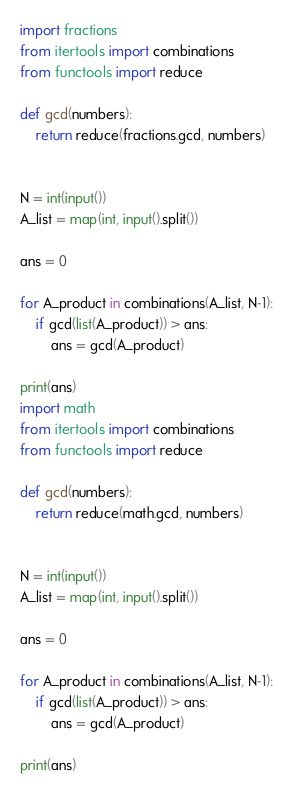<code> <loc_0><loc_0><loc_500><loc_500><_Python_>import fractions
from itertools import combinations
from functools import reduce
 
def gcd(numbers):
    return reduce(fractions.gcd, numbers)
 
 
N = int(input())
A_list = map(int, input().split())
 
ans = 0
 
for A_product in combinations(A_list, N-1):
    if gcd(list(A_product)) > ans:
        ans = gcd(A_product)
 
print(ans)
import math
from itertools import combinations
from functools import reduce

def gcd(numbers):
    return reduce(math.gcd, numbers)


N = int(input())
A_list = map(int, input().split())

ans = 0

for A_product in combinations(A_list, N-1):
    if gcd(list(A_product)) > ans:
        ans = gcd(A_product)

print(ans)
</code> 